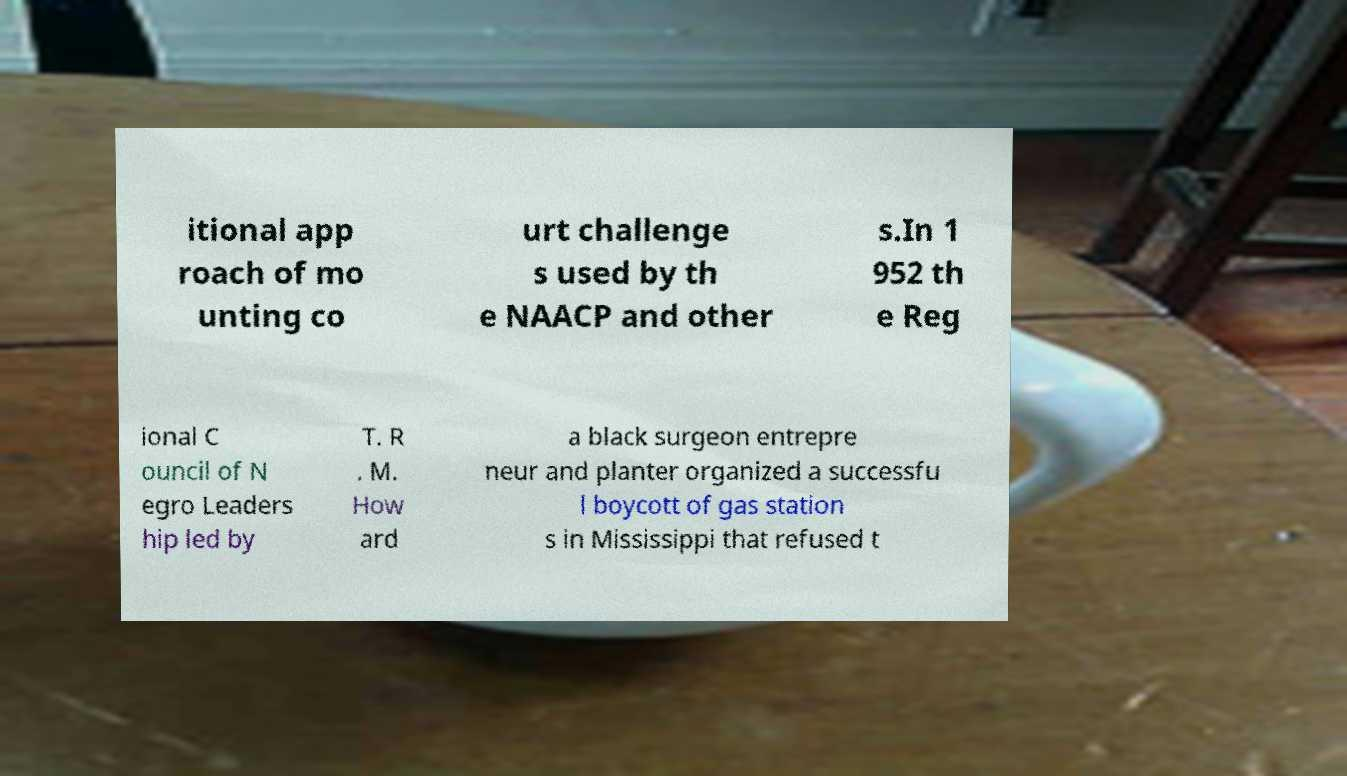What messages or text are displayed in this image? I need them in a readable, typed format. itional app roach of mo unting co urt challenge s used by th e NAACP and other s.In 1 952 th e Reg ional C ouncil of N egro Leaders hip led by T. R . M. How ard a black surgeon entrepre neur and planter organized a successfu l boycott of gas station s in Mississippi that refused t 